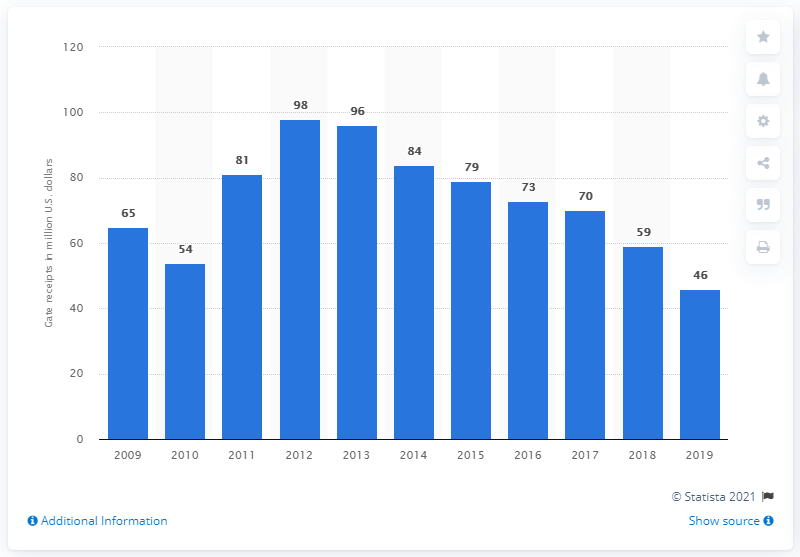Give some essential details in this illustration. In 2019, the gate receipts of the Detroit Tigers were $46. 